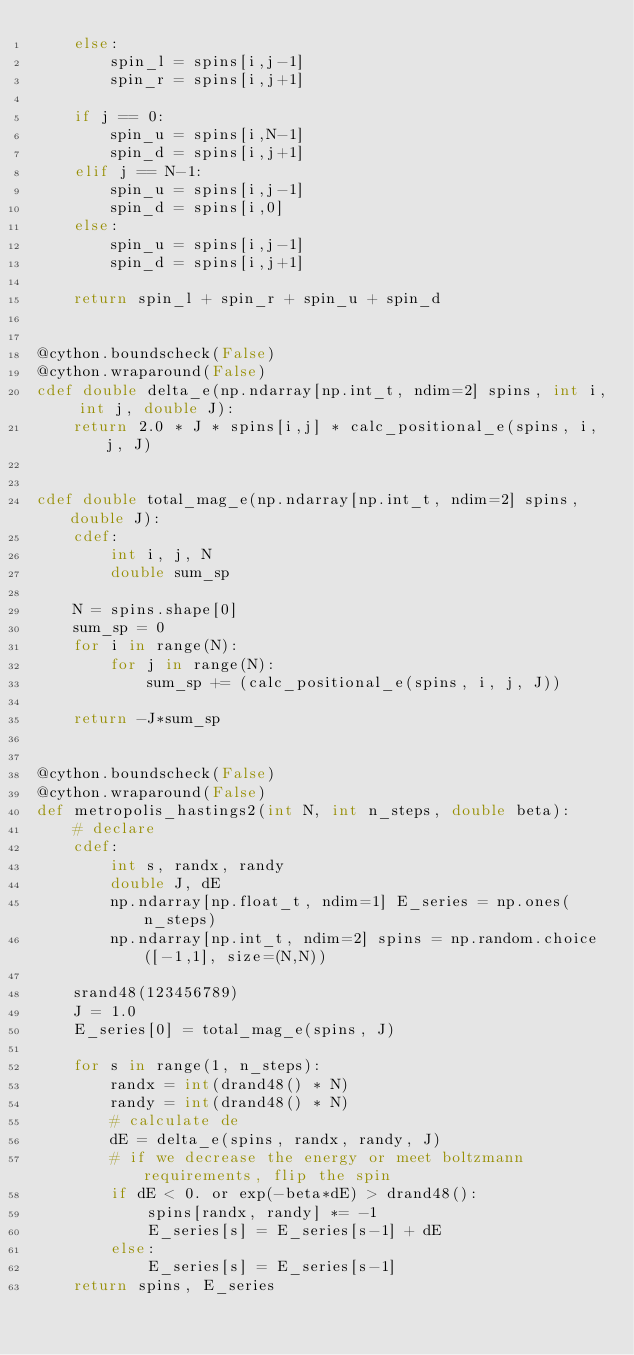<code> <loc_0><loc_0><loc_500><loc_500><_Cython_>    else:
        spin_l = spins[i,j-1]
        spin_r = spins[i,j+1]

    if j == 0:
        spin_u = spins[i,N-1]
        spin_d = spins[i,j+1]
    elif j == N-1:
        spin_u = spins[i,j-1]
        spin_d = spins[i,0]
    else:
        spin_u = spins[i,j-1]
        spin_d = spins[i,j+1]

    return spin_l + spin_r + spin_u + spin_d


@cython.boundscheck(False)
@cython.wraparound(False)
cdef double delta_e(np.ndarray[np.int_t, ndim=2] spins, int i, int j, double J):
    return 2.0 * J * spins[i,j] * calc_positional_e(spins, i, j, J)


cdef double total_mag_e(np.ndarray[np.int_t, ndim=2] spins, double J):
    cdef:
        int i, j, N
        double sum_sp

    N = spins.shape[0]
    sum_sp = 0
    for i in range(N):
        for j in range(N):
            sum_sp += (calc_positional_e(spins, i, j, J))

    return -J*sum_sp


@cython.boundscheck(False)
@cython.wraparound(False)
def metropolis_hastings2(int N, int n_steps, double beta):
    # declare
    cdef:
        int s, randx, randy
        double J, dE
        np.ndarray[np.float_t, ndim=1] E_series = np.ones(n_steps)
        np.ndarray[np.int_t, ndim=2] spins = np.random.choice([-1,1], size=(N,N))

    srand48(123456789)
    J = 1.0
    E_series[0] = total_mag_e(spins, J)

    for s in range(1, n_steps):
        randx = int(drand48() * N)
        randy = int(drand48() * N)
        # calculate de
        dE = delta_e(spins, randx, randy, J)
        # if we decrease the energy or meet boltzmann requirements, flip the spin
        if dE < 0. or exp(-beta*dE) > drand48():
            spins[randx, randy] *= -1
            E_series[s] = E_series[s-1] + dE
        else:
            E_series[s] = E_series[s-1]
    return spins, E_series</code> 